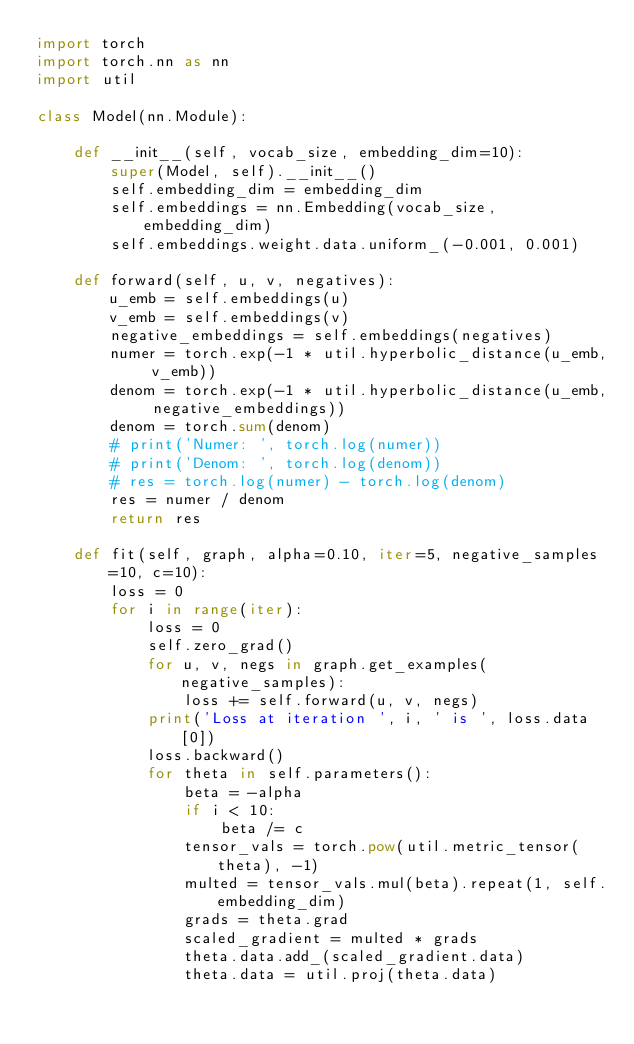Convert code to text. <code><loc_0><loc_0><loc_500><loc_500><_Python_>import torch
import torch.nn as nn
import util

class Model(nn.Module):

    def __init__(self, vocab_size, embedding_dim=10):
        super(Model, self).__init__()
        self.embedding_dim = embedding_dim
        self.embeddings = nn.Embedding(vocab_size, embedding_dim)
        self.embeddings.weight.data.uniform_(-0.001, 0.001)

    def forward(self, u, v, negatives):
        u_emb = self.embeddings(u)
        v_emb = self.embeddings(v)
        negative_embeddings = self.embeddings(negatives)
        numer = torch.exp(-1 * util.hyperbolic_distance(u_emb, v_emb))
        denom = torch.exp(-1 * util.hyperbolic_distance(u_emb, negative_embeddings))
        denom = torch.sum(denom)
        # print('Numer: ', torch.log(numer))
        # print('Denom: ', torch.log(denom))
        # res = torch.log(numer) - torch.log(denom)
        res = numer / denom
        return res

    def fit(self, graph, alpha=0.10, iter=5, negative_samples=10, c=10):
        loss = 0
        for i in range(iter):
            loss = 0
            self.zero_grad()
            for u, v, negs in graph.get_examples(negative_samples):
                loss += self.forward(u, v, negs)
            print('Loss at iteration ', i, ' is ', loss.data[0])
            loss.backward()
            for theta in self.parameters():
                beta = -alpha
                if i < 10:
                    beta /= c
                tensor_vals = torch.pow(util.metric_tensor(theta), -1)
                multed = tensor_vals.mul(beta).repeat(1, self.embedding_dim)
                grads = theta.grad
                scaled_gradient = multed * grads
                theta.data.add_(scaled_gradient.data)
                theta.data = util.proj(theta.data)









</code> 